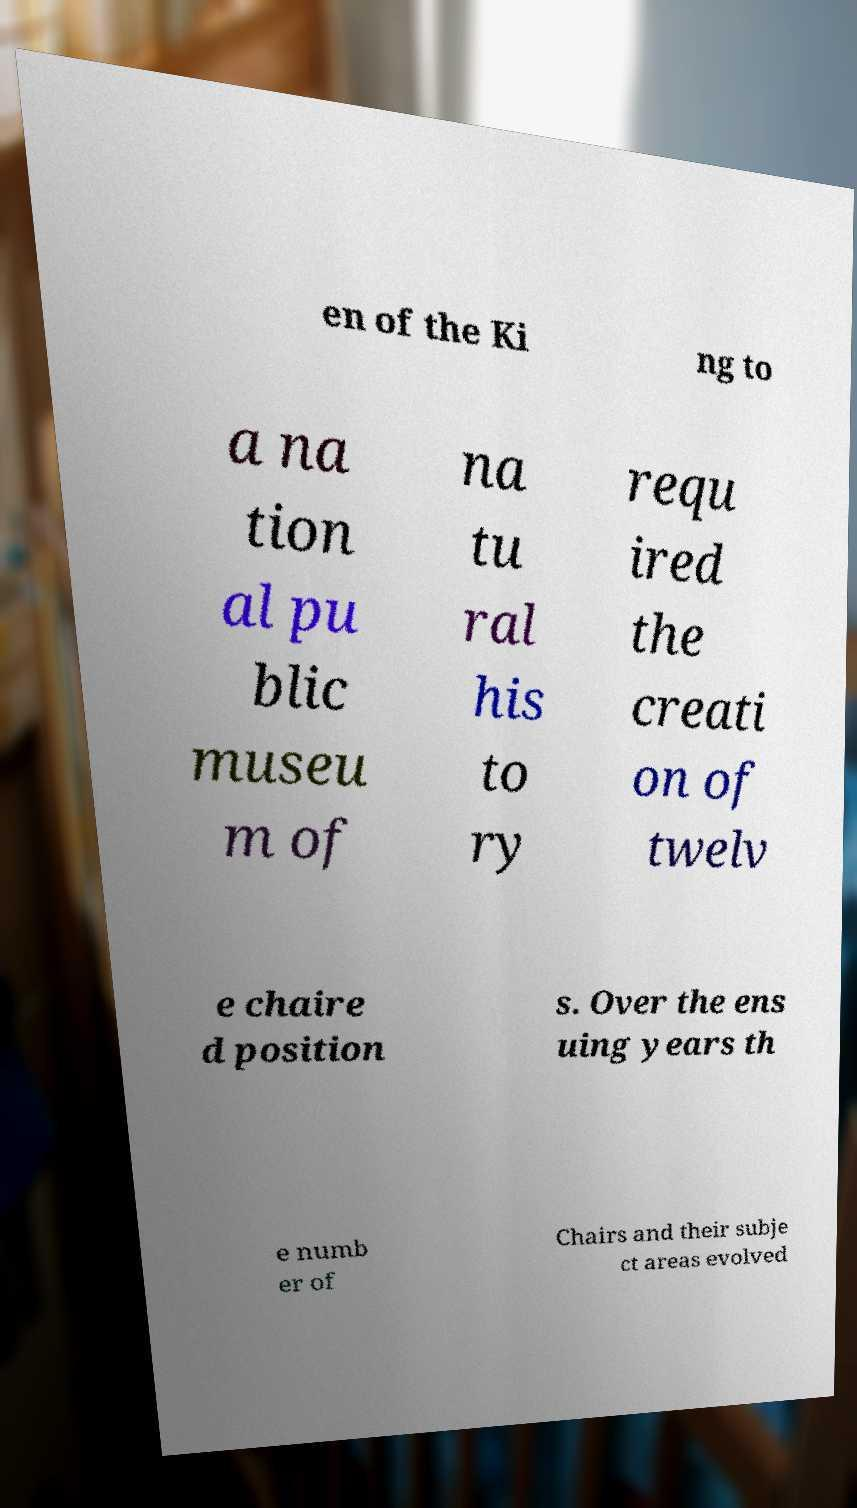There's text embedded in this image that I need extracted. Can you transcribe it verbatim? en of the Ki ng to a na tion al pu blic museu m of na tu ral his to ry requ ired the creati on of twelv e chaire d position s. Over the ens uing years th e numb er of Chairs and their subje ct areas evolved 